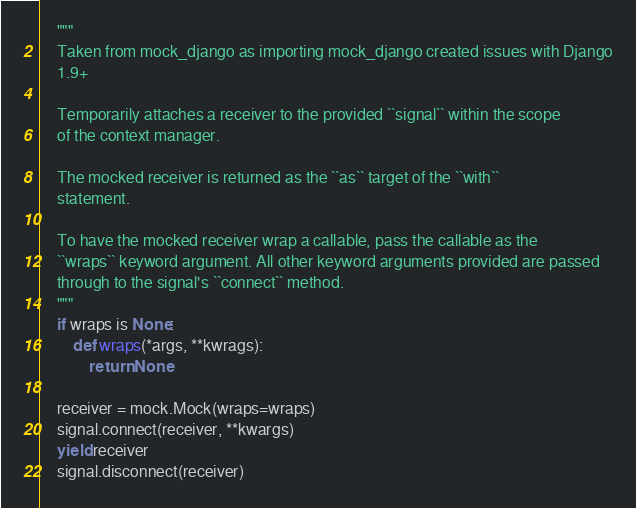<code> <loc_0><loc_0><loc_500><loc_500><_Python_>    """
    Taken from mock_django as importing mock_django created issues with Django
    1.9+

    Temporarily attaches a receiver to the provided ``signal`` within the scope
    of the context manager.

    The mocked receiver is returned as the ``as`` target of the ``with``
    statement.

    To have the mocked receiver wrap a callable, pass the callable as the
    ``wraps`` keyword argument. All other keyword arguments provided are passed
    through to the signal's ``connect`` method.
    """
    if wraps is None:
        def wraps(*args, **kwrags):
            return None

    receiver = mock.Mock(wraps=wraps)
    signal.connect(receiver, **kwargs)
    yield receiver
    signal.disconnect(receiver)
</code> 